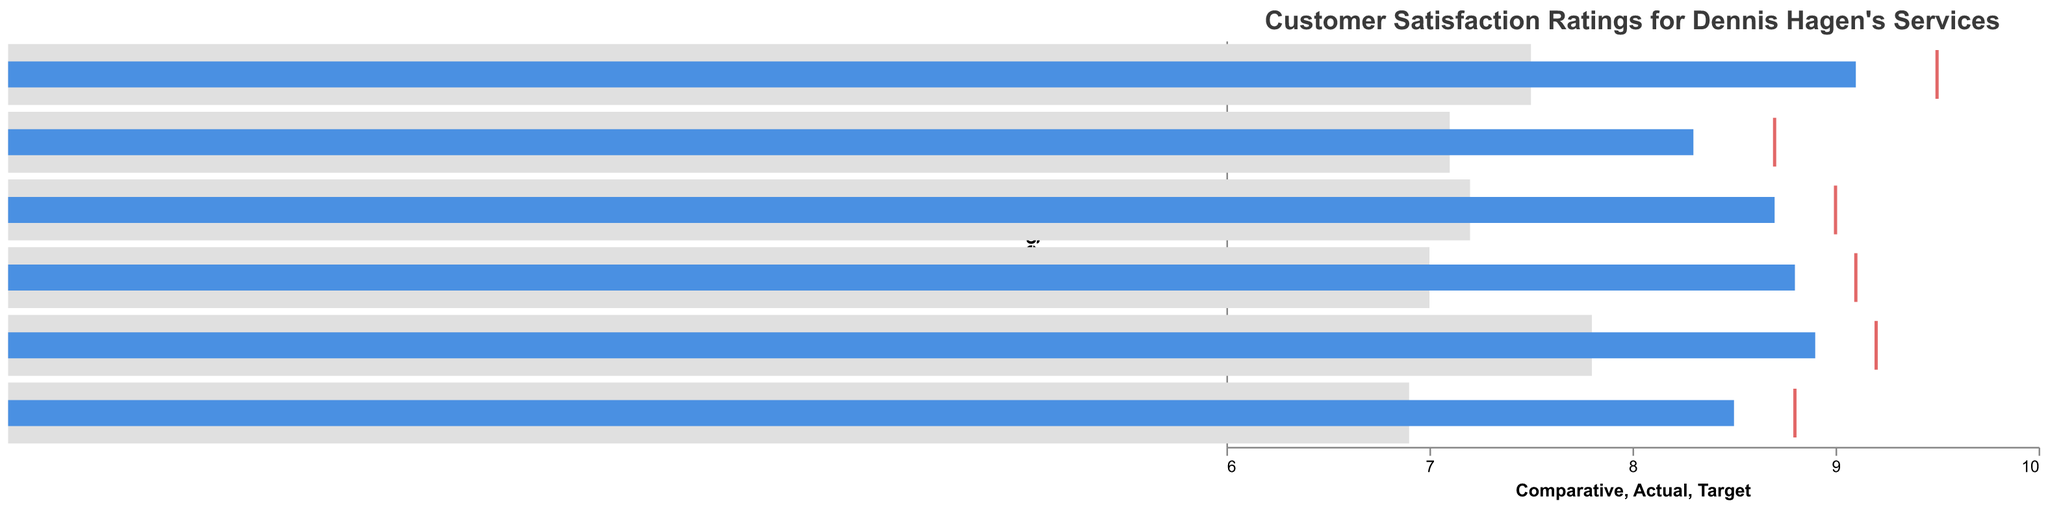What is the title of the chart? The title of the chart is usually displayed at the top, introducing the main topic or content of the visualized data. In this case, the title reads "Customer Satisfaction Ratings for Dennis Hagen's Services."
Answer: Customer Satisfaction Ratings for Dennis Hagen's Services Which category has the highest comparative rating? To find the highest comparative rating, look at the 'Comparative' bar for each category. The highest comparative rating is for "Product Quality" with a value of 7.8.
Answer: Product Quality What is the difference between the actual and comparative ratings for Customer Service? The actual rating for Customer Service is 9.1, and the comparative rating is 7.5. Subtract the comparative rating from the actual rating: 9.1 - 7.5 = 1.6.
Answer: 1.6 Which two categories have the smallest and largest differences between actual and target ratings? Calculate the difference between actual and target ratings for each category, then compare them.
- Overall Satisfaction: 9.0 - 8.7 = 0.3
- Customer Service: 9.5 - 9.1 = 0.4
- Product Quality: 9.2 - 8.9 = 0.3
- Value for Money: 8.8 - 8.5 = 0.3
- Delivery Speed: 8.7 - 8.3 = 0.4
- Problem Resolution: 9.1 - 8.8 = 0.3
The smallest differences are in Overall Satisfaction, Product Quality, Value for Money, and Problem Resolution (all 0.3). The largest differences are in Customer Service and Delivery Speed (both 0.4).
Answer: Overall Satisfaction, Product Quality, Value for Money, Problem Resolution (smallest), Customer Service, Delivery Speed (largest) Which category is closest to its target rating? To determine which category is closest to its target rating, compare the actual and target ratings for each category. The smallest difference will indicate the closest category.
- Overall Satisfaction: 0.3
- Customer Service: 0.4
- Product Quality: 0.3
- Value for Money: 0.3
- Delivery Speed: 0.4
- Problem Resolution: 0.3
Categories with a difference of 0.3 are Overall Satisfaction, Product Quality, Value for Money, and Problem Resolution.
Answer: Overall Satisfaction, Product Quality, Value for Money, Problem Resolution How do the actual ratings compare to the comparative benchmarks across all categories? Compare each actual rating against its comparative benchmark:
- Overall Satisfaction: Actual 8.7 vs Comparative 7.2 (higher)
- Customer Service: Actual 9.1 vs Comparative 7.5 (higher)
- Product Quality: Actual 8.9 vs Comparative 7.8 (higher)
- Value for Money: Actual 8.5 vs Comparative 6.9 (higher)
- Delivery Speed: Actual 8.3 vs Comparative 7.1 (higher)
- Problem Resolution: Actual 8.8 vs Comparative 7.0 (higher)
For all categories, the actual ratings are higher than the comparative benchmarks.
Answer: Higher in all categories Which category has the lowest actual rating? To find the lowest actual rating, look at the 'Actual' bar for each category. The lowest actual rating is for "Delivery Speed" with a value of 8.3.
Answer: Delivery Speed What is the average of all the target ratings? Calculate the sum of all target ratings and then find the average:
(9.0 + 9.5 + 9.2 + 8.8 + 8.7 + 9.1) = 54.3
The number of categories is 6, so the average is 54.3 / 6 = 9.05.
Answer: 9.05 